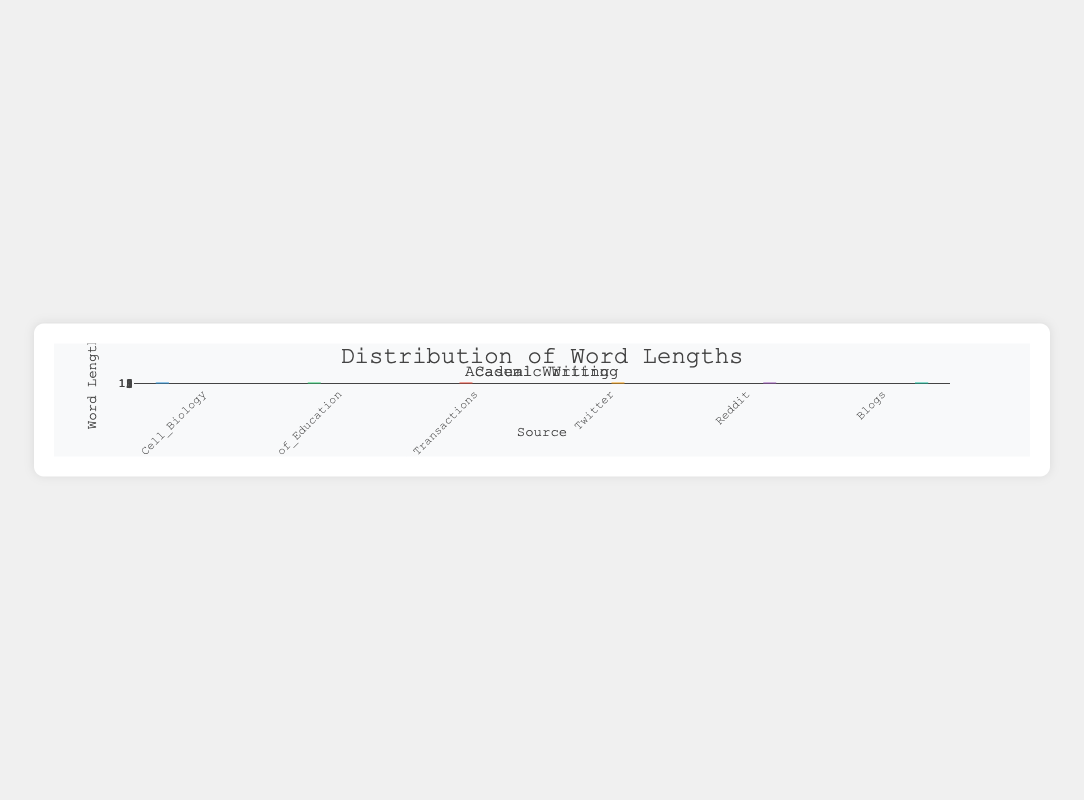What is the title of the chart? The title of the chart is located at the top and reads "Word Length Distribution: Academic vs. Casual Writing".
Answer: Word Length Distribution: Academic vs. Casual Writing How many sources are represented in the academic writing category? There are three sources in the academic writing category: Nature_Cell_Biology, Journal_of_Education, and IEEE_Transactions.
Answer: Three Which source in casual writing has the lowest median word length? By visually examining the boxes, the median, represented by the line inside the boxes, is lowest for Twitter in casual writing.
Answer: Twitter What is the range of word lengths in Nature_Cell_Biology? The whiskers of the boxplot for Nature_Cell_Biology extend from 4 to 12, indicating that the word lengths range between these values.
Answer: 4 to 12 Which source has the highest maximum word length, academic or casual writing? The maximum value in IEEE_Transactions (11) is the highest across all sources.
Answer: Academic Comparing the medians, does IEEE_Transactions have a higher median word length than Reddit? The box plot for IEEE_Transactions has a median around 8, while Reddit's median looks close to 5. This shows IEEE_Transactions has a higher median word length.
Answer: Yes Which source, between Twitter and Journal_of_Education, has more outliers? By observing the box plots, Twitter has more marked outliers in the form of dots outside the whiskers than Journal_of_Education.
Answer: Twitter What is the median word length in Blogs? The median is represented by the line inside the box for Blogs, which appears to be about 5.
Answer: 5 Is there a noticeable difference in word length distribution between academic and casual writing? Academic writing exhibits generally higher medians and ranges in word lengths compared to casual writing, as seen in their box plots' higher positions and larger ranges.
Answer: Yes What is the interquartile range (IQR) of word length for IEEE_Transactions? The IQR is the difference between the first quartile (Q1) and the third quartile (Q3). For IEEE_Transactions, Q1 is around 7 and Q3 is around 9, thus IQR = 9 - 7.
Answer: 2 